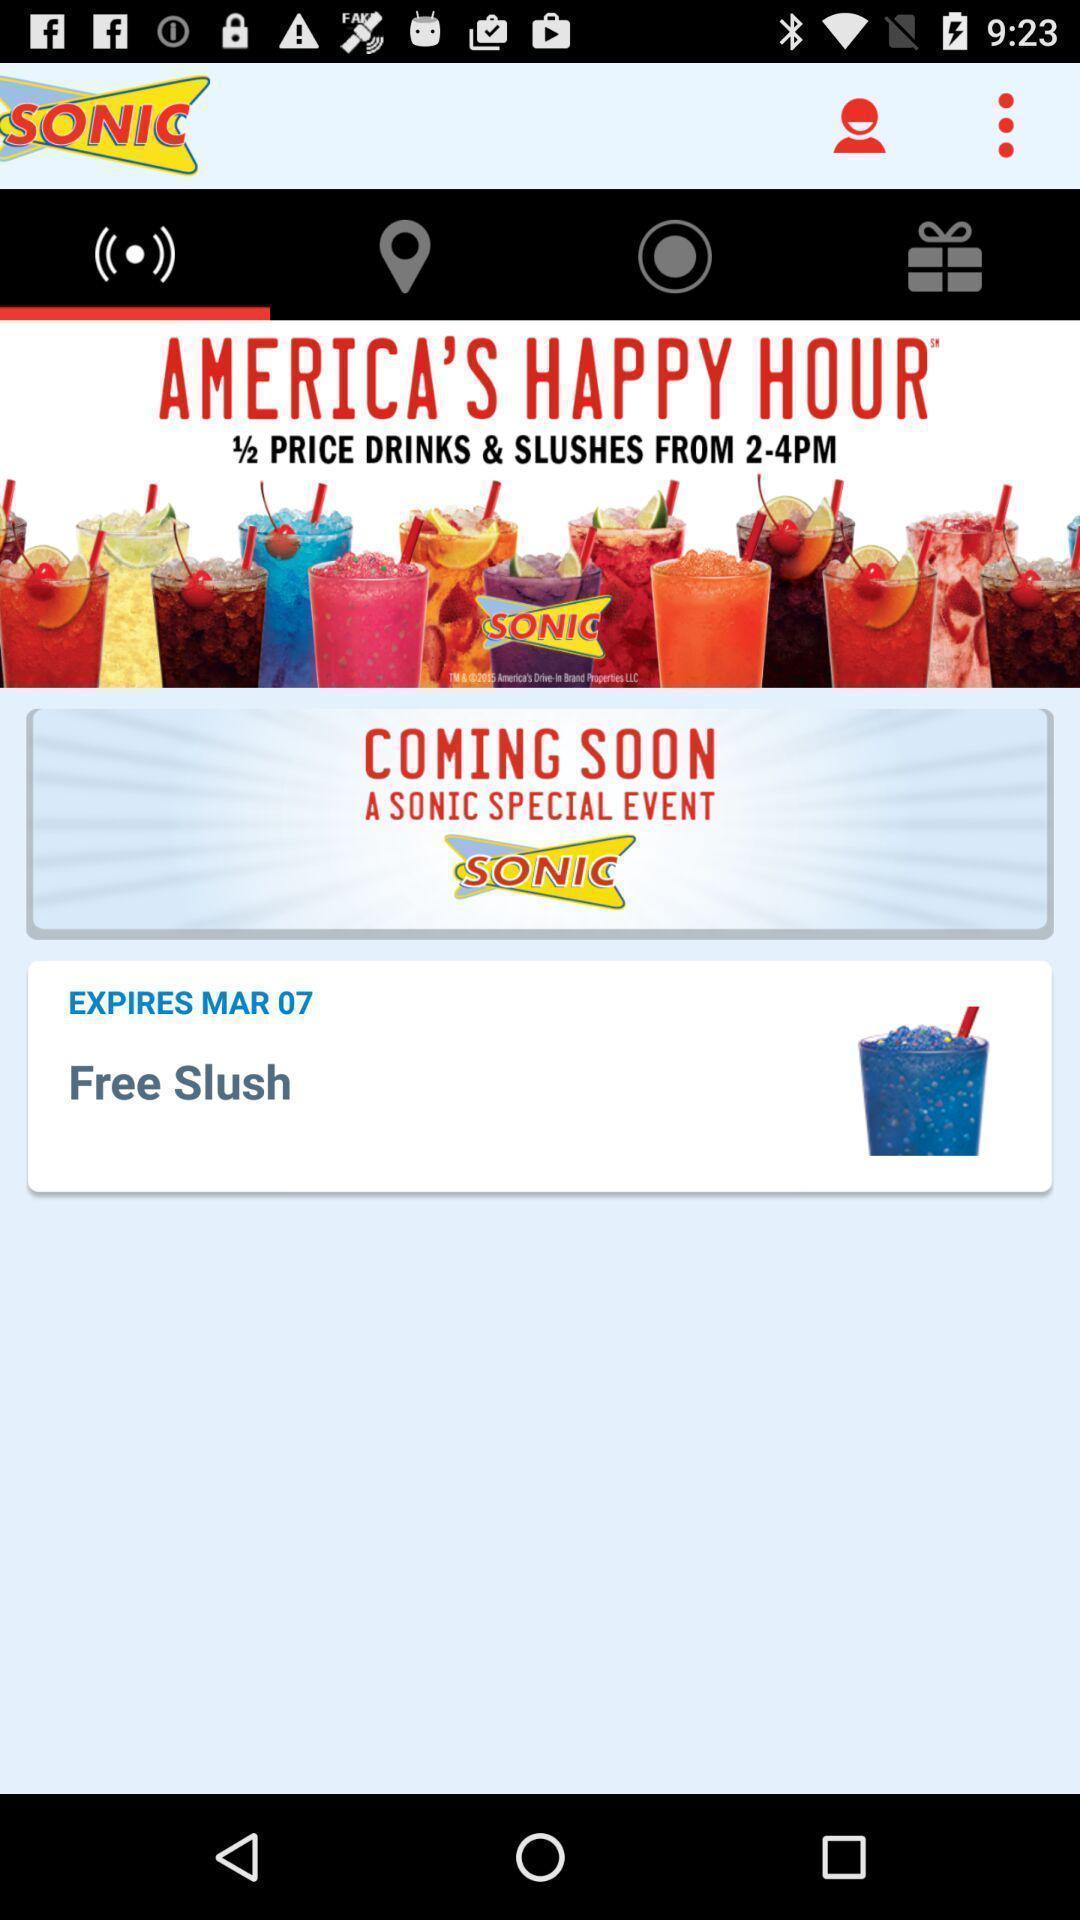Tell me about the visual elements in this screen capture. Page displays an advertisement in app. 